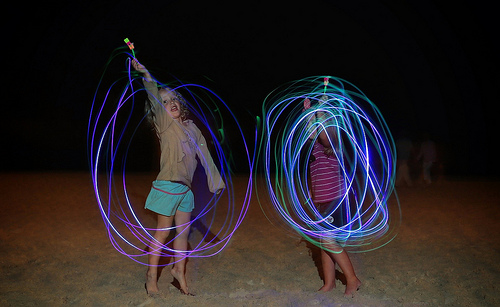<image>
Is there a girl to the left of the toy? No. The girl is not to the left of the toy. From this viewpoint, they have a different horizontal relationship. 